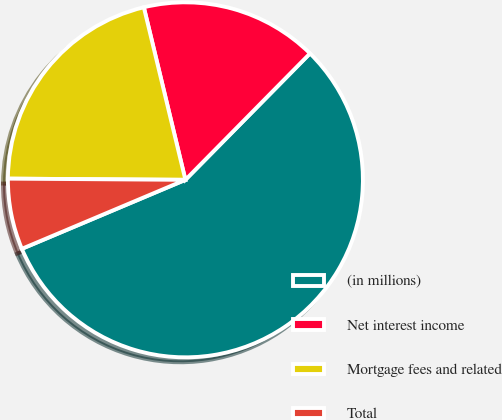Convert chart. <chart><loc_0><loc_0><loc_500><loc_500><pie_chart><fcel>(in millions)<fcel>Net interest income<fcel>Mortgage fees and related<fcel>Total<nl><fcel>56.26%<fcel>16.15%<fcel>21.13%<fcel>6.46%<nl></chart> 